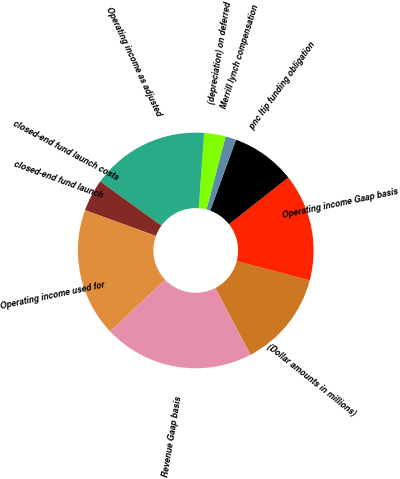Convert chart to OTSL. <chart><loc_0><loc_0><loc_500><loc_500><pie_chart><fcel>(Dollar amounts in millions)<fcel>Operating income Gaap basis<fcel>pnc ltip funding obligation<fcel>Merrill lynch compensation<fcel>(depreciation) on deferred<fcel>Operating income as adjusted<fcel>closed-end fund launch costs<fcel>closed-end fund launch<fcel>Operating income used for<fcel>Revenue Gaap basis<nl><fcel>13.23%<fcel>14.7%<fcel>8.82%<fcel>1.47%<fcel>2.94%<fcel>16.17%<fcel>4.41%<fcel>0.0%<fcel>17.64%<fcel>20.58%<nl></chart> 